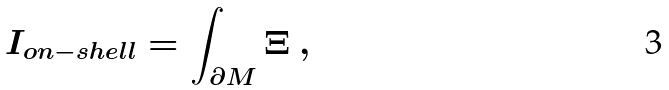Convert formula to latex. <formula><loc_0><loc_0><loc_500><loc_500>I _ { o n - s h e l l } = \int _ { \partial M } \Xi \ ,</formula> 